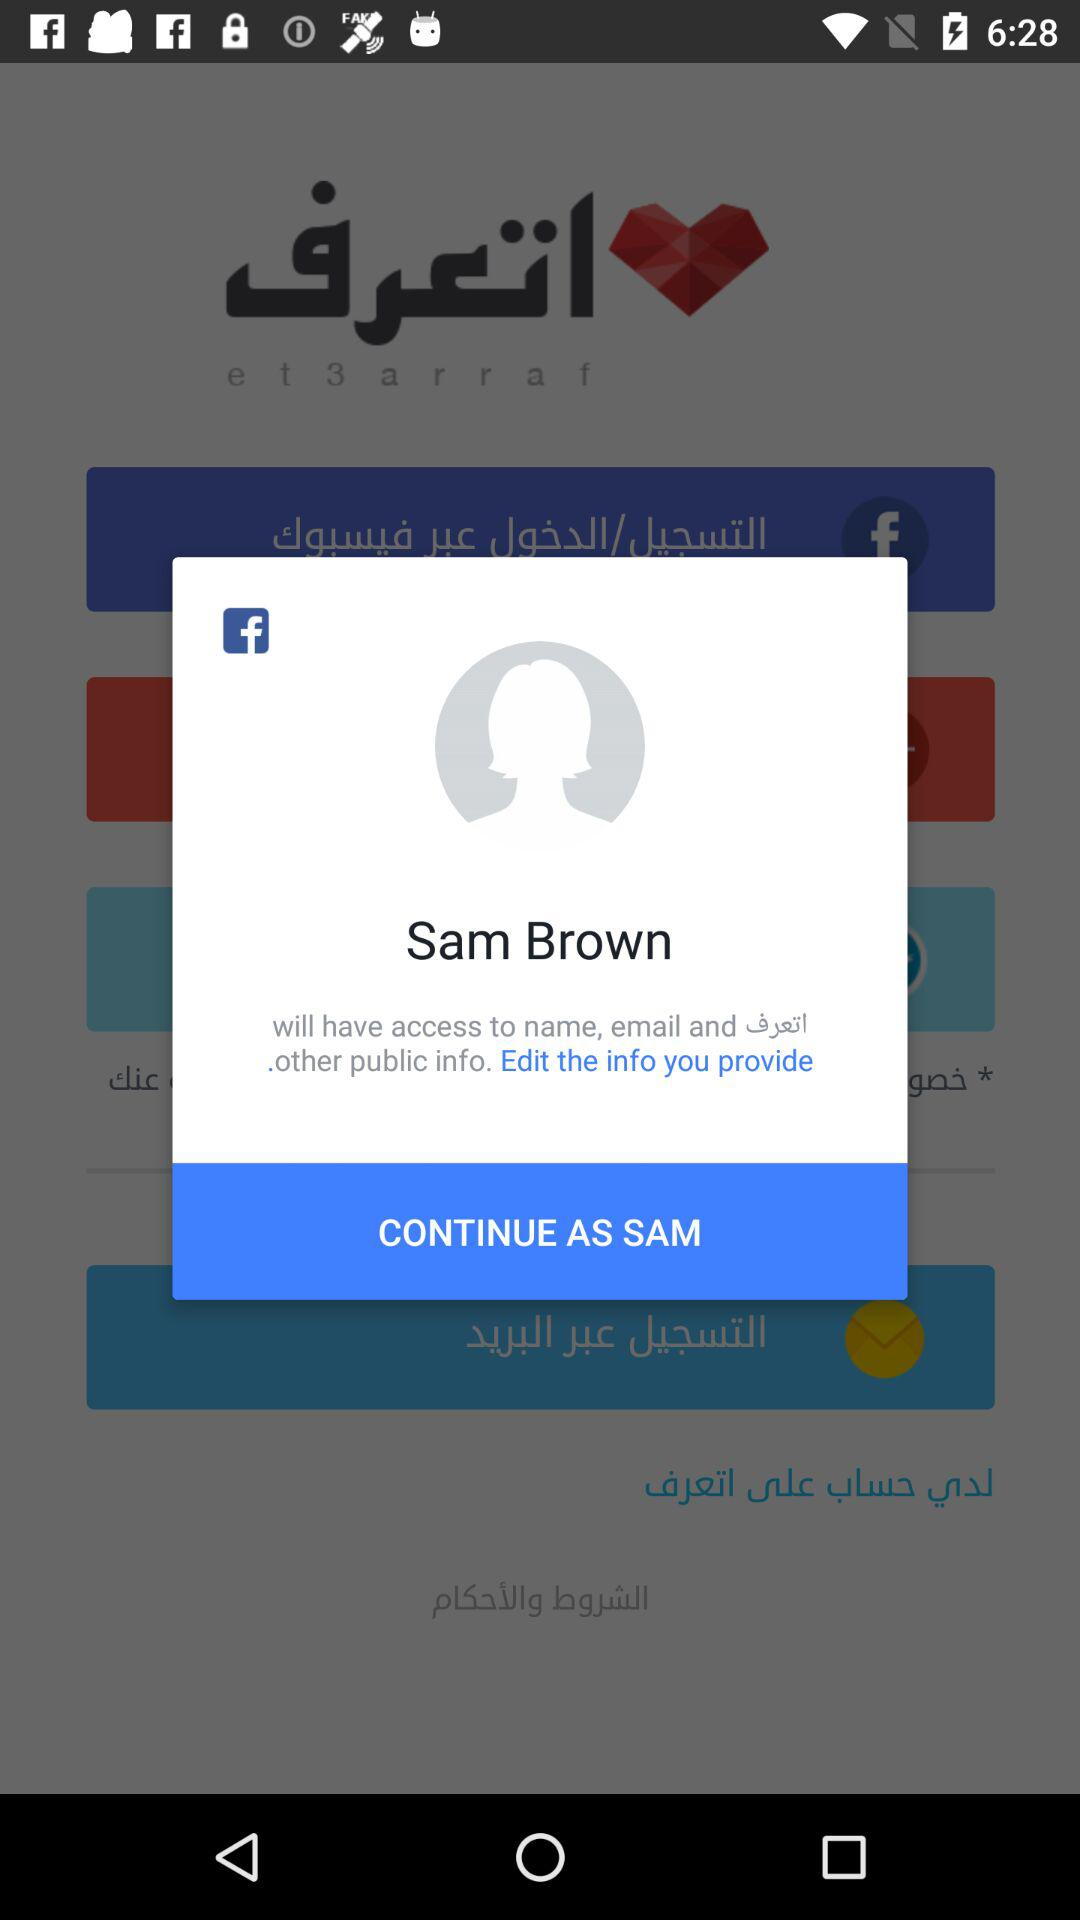What is the login name? The login name is Sam Brown. 